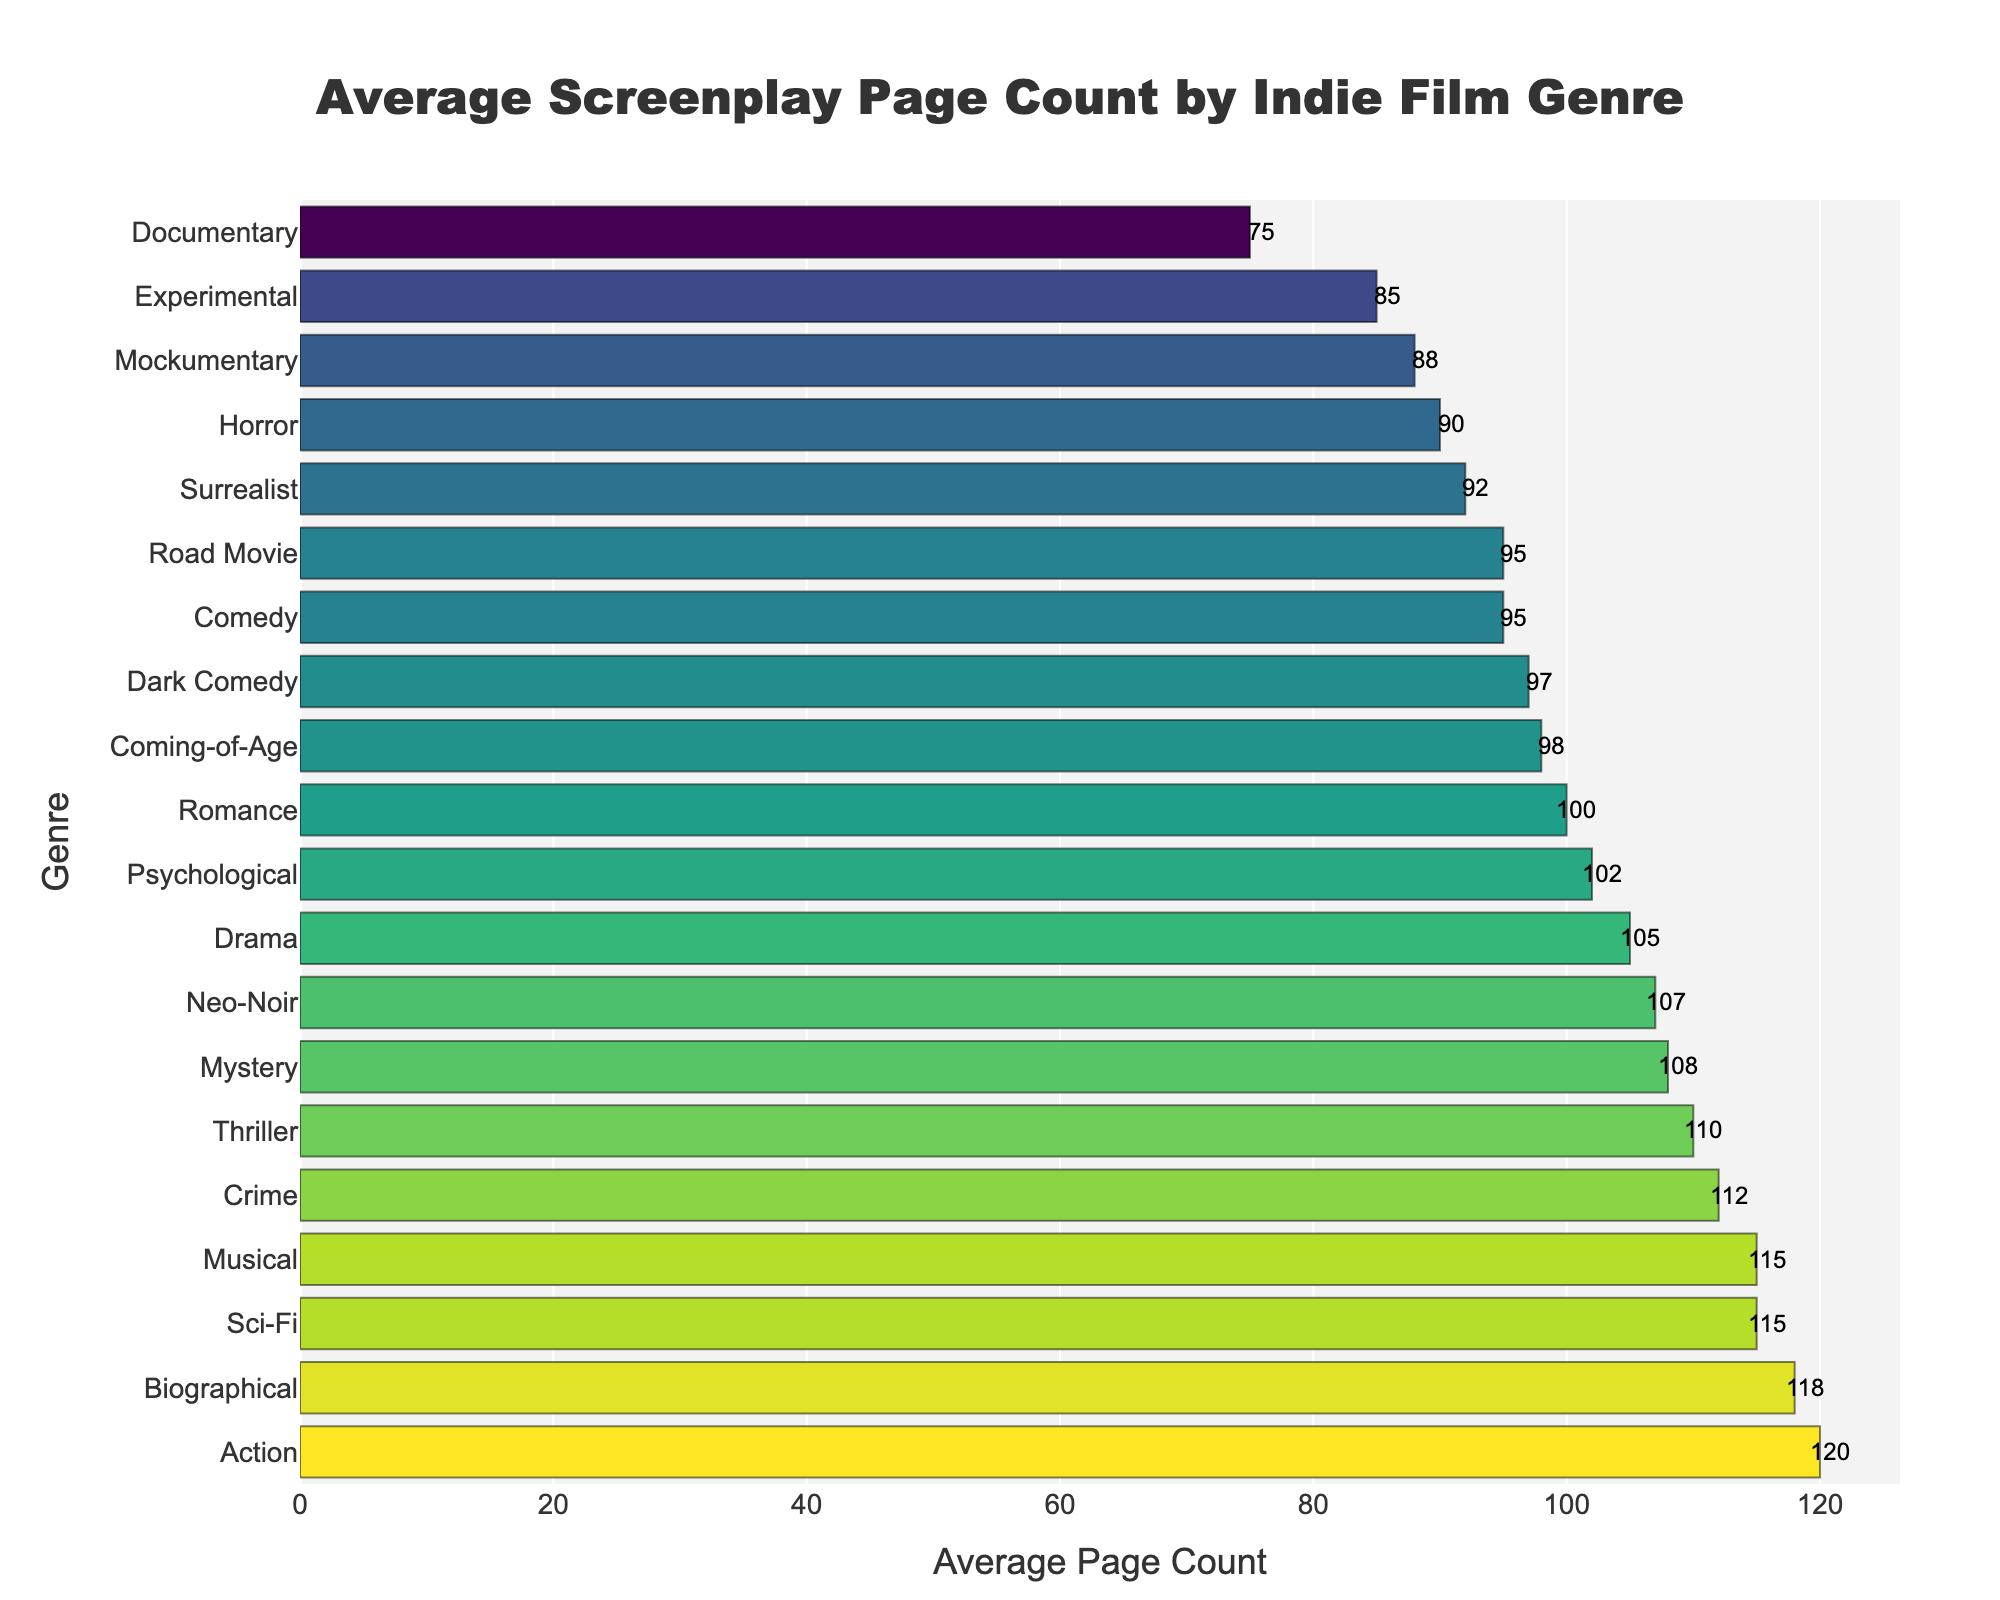what genre has the highest average screenplay page count? The genre with the highest average screenplay page count is the one with the longest bar at the top of the chart. The longest bar corresponds to the "Action" genre, which has an average page count of 120.
Answer: Action Which genre has a higher average page count, Drama or Comedy? To determine which genre has a higher average page count, compare the lengths of the "Drama" and "Comedy" bars. The "Drama" genre bar is longer, indicating an average page count of 105, while the "Comedy" genre has an average page count of only 95.
Answer: Drama What's the difference in the average page count between the genre with the highest count and the genre with the lowest count? The genre with the highest average page count is "Action" with 120 pages, and the genre with the lowest count is "Documentary" with 75 pages. The difference between them is calculated as 120 - 75 = 45 pages.
Answer: 45 What is the median average page count of all listed genres? To find the median average page count, first list all the page counts in numerical order: 75, 85, 88, 90, 92, 95, 95, 97, 98, 100, 102, 105, 107, 108, 110, 112, 115, 115, 118, 120. Since there are 20 values, the median is the average of the 10th and 11th values: (100+102)/2 = 101 pages.
Answer: 101 Which two genres have the closest average page counts and what are those counts? To find the closest genres, identify which bars are almost equal in length. "Romance" and "Psychological" have the closest counts, with average page counts of 100 and 102 pages, respectively.
Answer: Romance and Psychological How many genres have an average page count greater than 100? Count the number of genres with bars extending beyond the 100-page mark. These genres are Action (120), Biographical (118), Musical (115), Sci-Fi (115), Crime (112), Thriller (110), Mystery (108), and Neo-Noir (107), totaling 8 genres.
Answer: 8 What is the average page count for Comedy, Road Movie, and Mockumentary genres combined? Compute the combined average by adding their counts and dividing by 3: (95 + 95 + 88) / 3 = 278 / 3 ≈ 92.67 pages.
Answer: 92.67 Which genre has a page count exactly in the middle of its range (the median genre)? The data is sorted to find the middle. With 20 genres, the 10th and 11th are "Romance" (100) and "Psychological" (102). There is no single median genre because the list is even.
Answer: Not applicable What is the range of average page counts among the listed genres? The range is computed by subtracting the smallest value from the largest one. The smallest value is 75 (Documentary) and the largest is 120 (Action). Thus, the range is 120 - 75 = 45 pages.
Answer: 45 pages 